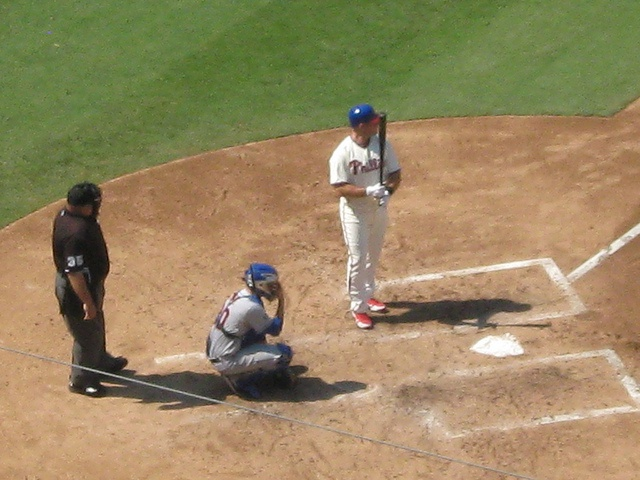Describe the objects in this image and their specific colors. I can see people in olive, black, maroon, and gray tones, people in olive, white, darkgray, and gray tones, people in olive, gray, black, darkgray, and tan tones, and baseball bat in olive, black, and gray tones in this image. 